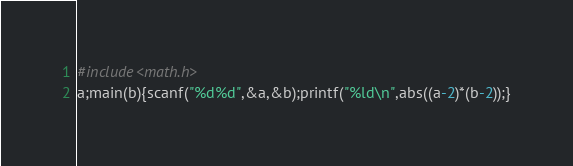<code> <loc_0><loc_0><loc_500><loc_500><_C_>#include<math.h>
a;main(b){scanf("%d%d",&a,&b);printf("%ld\n",abs((a-2)*(b-2));}</code> 